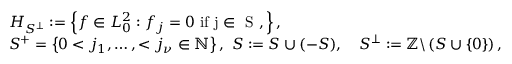<formula> <loc_0><loc_0><loc_500><loc_500>\begin{array} { r l } & { H _ { S ^ { \perp } } \colon = \left \{ f \in L _ { 0 } ^ { 2 } \colon f _ { j } = 0 i f j \in S , \right \} , } \\ & { S ^ { + } = \left \{ 0 < j _ { 1 } , \dots , < j _ { \nu } \in \mathbb { N } \right \} , \ S \colon = S \cup ( - S ) , \quad S ^ { \perp } \colon = \mathbb { Z } \ \left ( S \cup \left \{ 0 \right \} \right ) , } \end{array}</formula> 